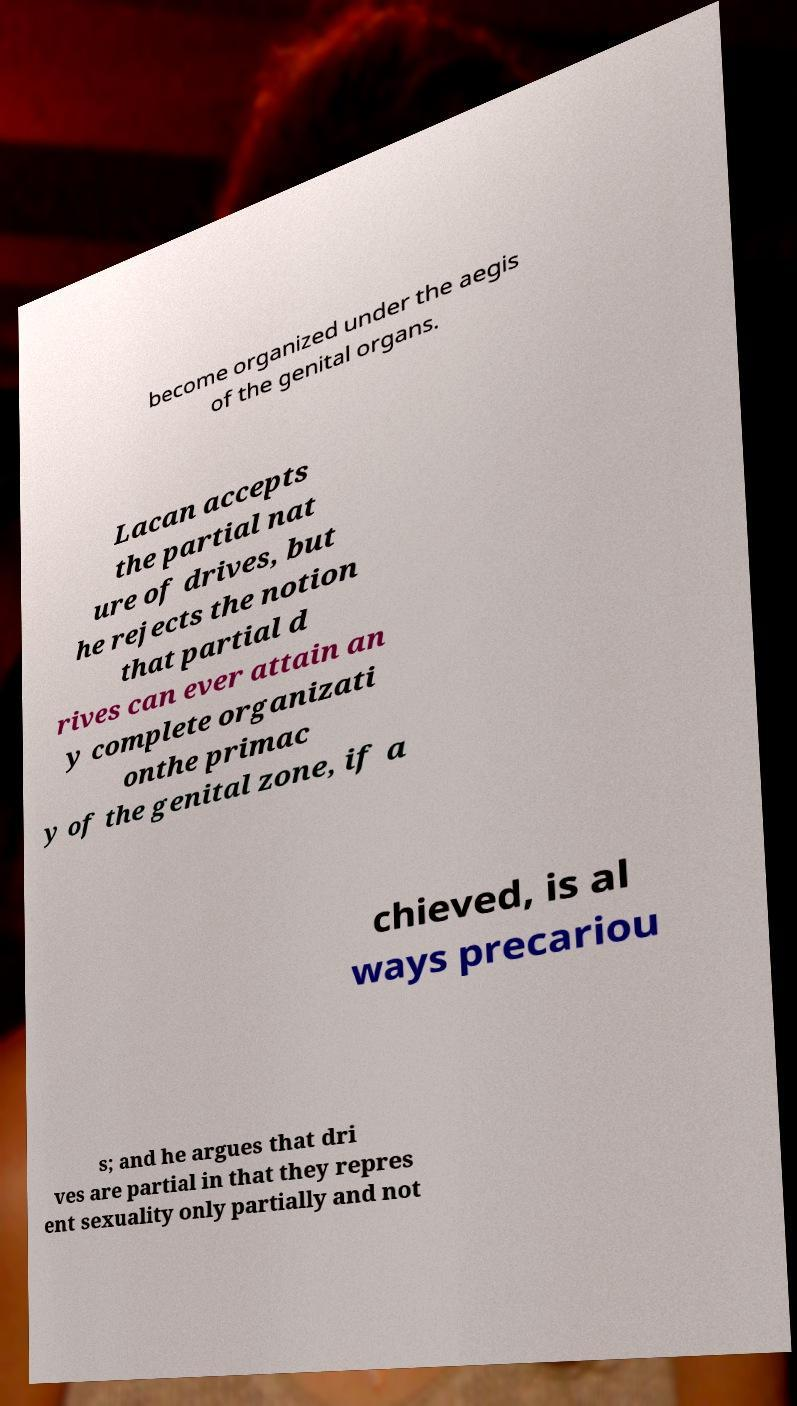Can you read and provide the text displayed in the image?This photo seems to have some interesting text. Can you extract and type it out for me? become organized under the aegis of the genital organs. Lacan accepts the partial nat ure of drives, but he rejects the notion that partial d rives can ever attain an y complete organizati onthe primac y of the genital zone, if a chieved, is al ways precariou s; and he argues that dri ves are partial in that they repres ent sexuality only partially and not 